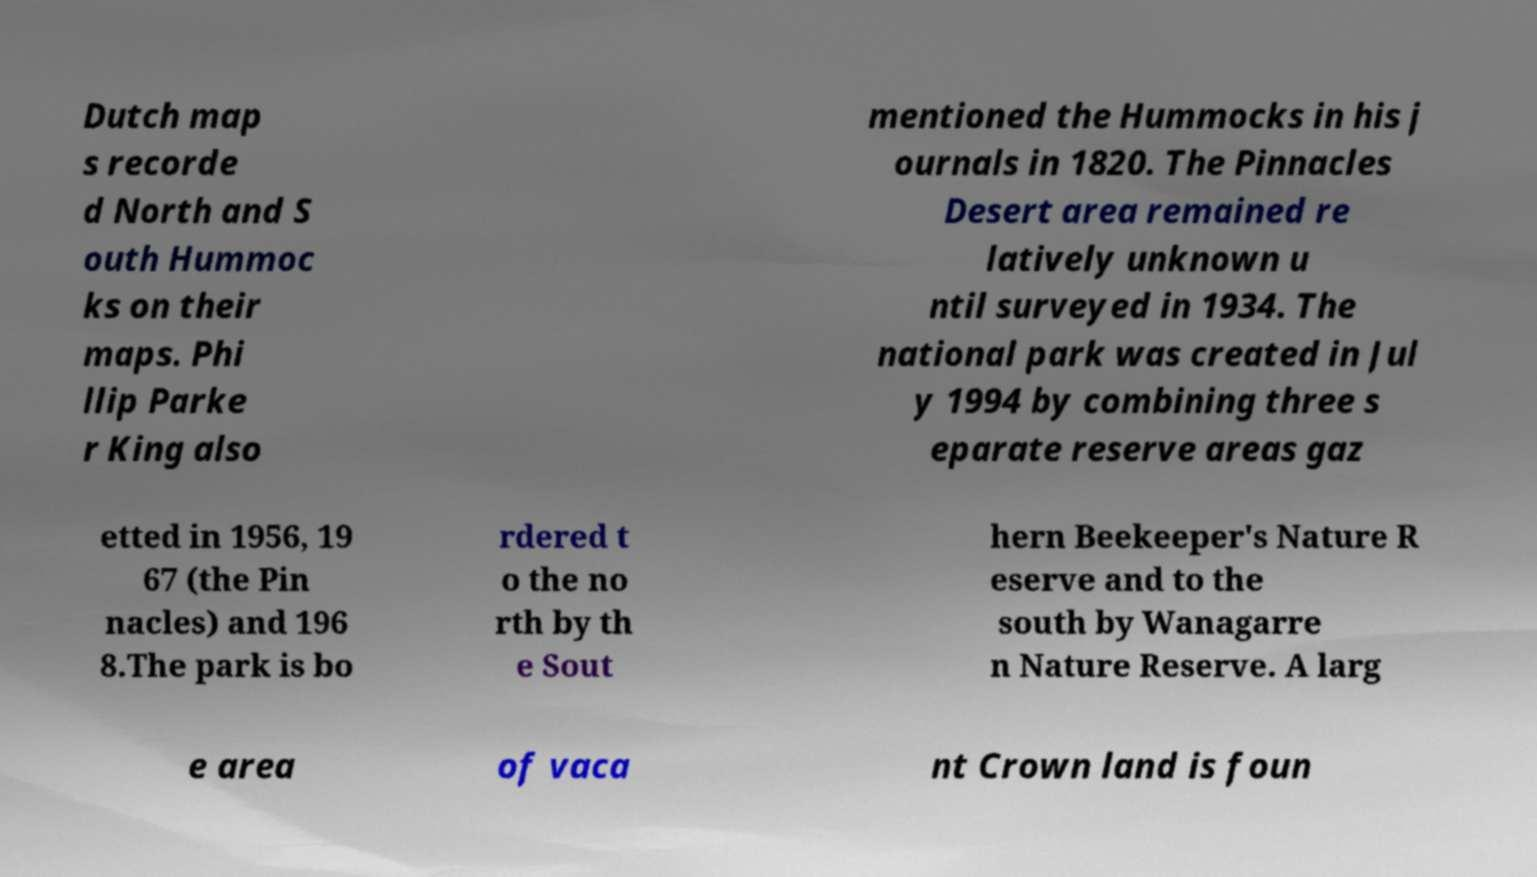Can you read and provide the text displayed in the image?This photo seems to have some interesting text. Can you extract and type it out for me? Dutch map s recorde d North and S outh Hummoc ks on their maps. Phi llip Parke r King also mentioned the Hummocks in his j ournals in 1820. The Pinnacles Desert area remained re latively unknown u ntil surveyed in 1934. The national park was created in Jul y 1994 by combining three s eparate reserve areas gaz etted in 1956, 19 67 (the Pin nacles) and 196 8.The park is bo rdered t o the no rth by th e Sout hern Beekeeper's Nature R eserve and to the south by Wanagarre n Nature Reserve. A larg e area of vaca nt Crown land is foun 